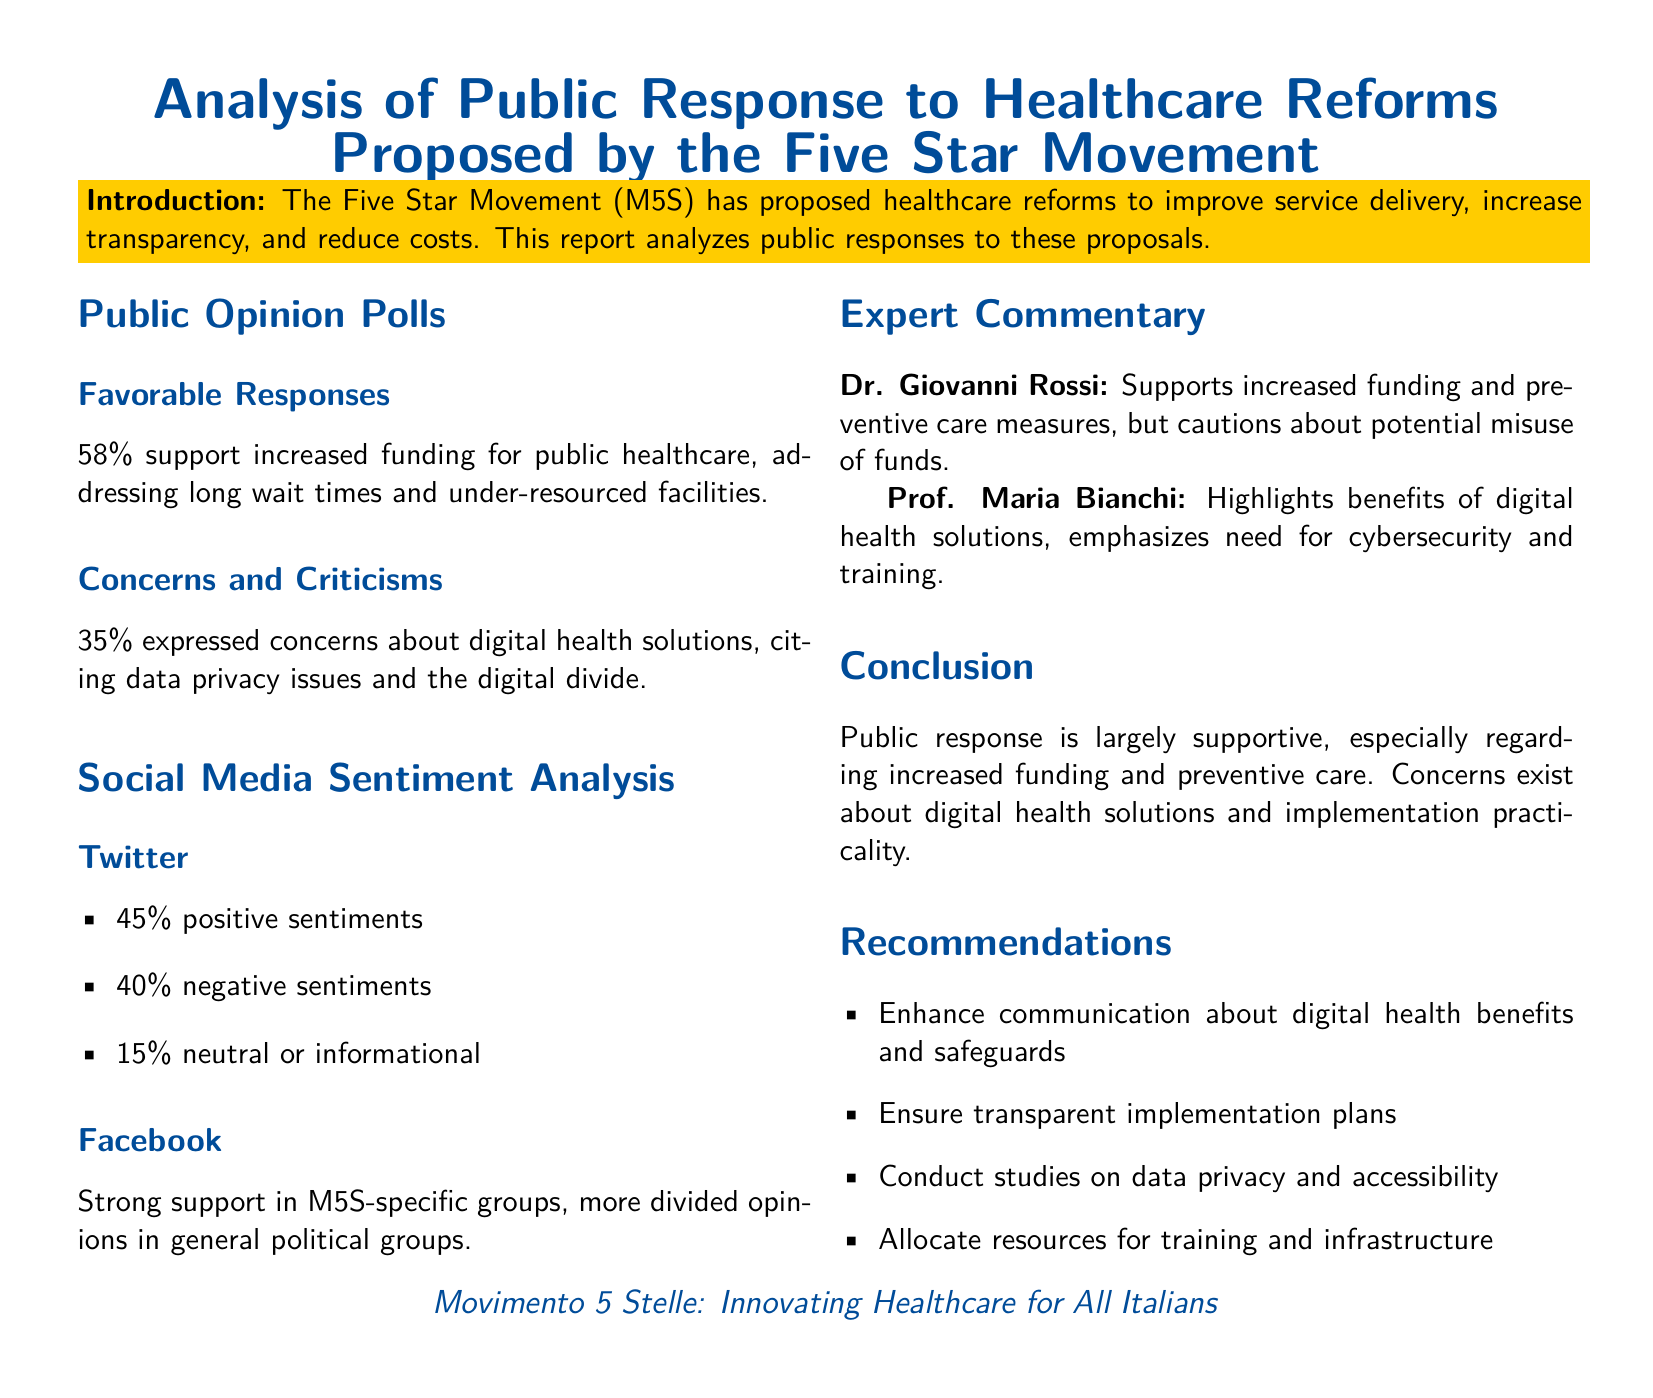what percentage of public supports increased funding for healthcare? The percentage of public that supports increased funding is explicitly stated in the report as 58%.
Answer: 58% what are the concerns raised about digital health solutions? The report specifically mentions that concerns include data privacy issues and the digital divide.
Answer: Data privacy issues and the digital divide what is the percentage of positive sentiments on Twitter? The document provides a breakdown of Twitter sentiments, indicating that 45% of sentiments are positive.
Answer: 45% who supports increased funding and preventive care measures? The report attributes support for increased funding and preventive care to Dr. Giovanni Rossi.
Answer: Dr. Giovanni Rossi what is the primary benefit highlighted by Prof. Maria Bianchi regarding digital health? Prof. Maria Bianchi highlights the benefits of digital health solutions in connection to cybersecurity and training.
Answer: Cybersecurity and training which social media platform showed strong support in M5S-specific groups? The document notes that Facebook showed strong support in M5S-specific groups.
Answer: Facebook what recommendation is given concerning digital health benefits? The report recommends enhancing communication about digital health benefits and safeguards.
Answer: Enhance communication about digital health benefits and safeguards what percentage of Facebook opinions are described as divided in general political groups? The document does not provide a specific percentage but indicates that opinions in general political groups are more divided.
Answer: More divided opinions what is the overall public response to the Five Star Movement's healthcare reforms? The conclusion states that public response is largely supportive of the proposed reforms.
Answer: Largely supportive 